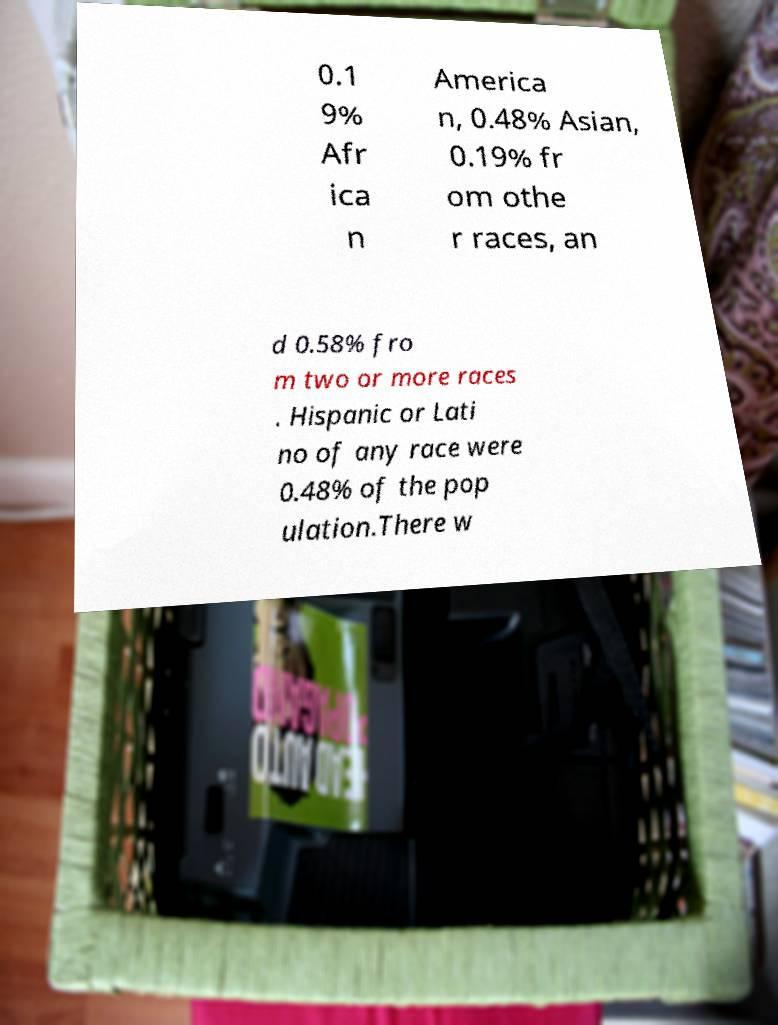Can you read and provide the text displayed in the image?This photo seems to have some interesting text. Can you extract and type it out for me? 0.1 9% Afr ica n America n, 0.48% Asian, 0.19% fr om othe r races, an d 0.58% fro m two or more races . Hispanic or Lati no of any race were 0.48% of the pop ulation.There w 